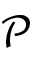Convert formula to latex. <formula><loc_0><loc_0><loc_500><loc_500>\ m a t h s c r { P }</formula> 